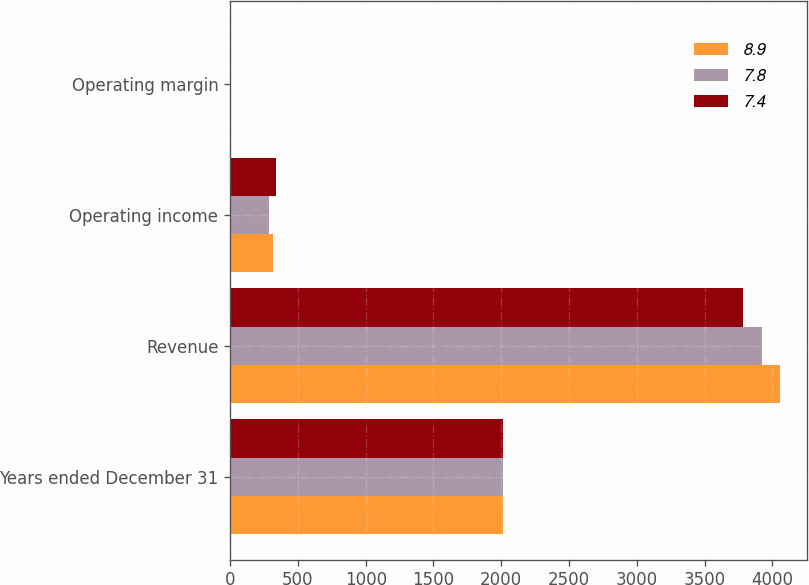<chart> <loc_0><loc_0><loc_500><loc_500><stacked_bar_chart><ecel><fcel>Years ended December 31<fcel>Revenue<fcel>Operating income<fcel>Operating margin<nl><fcel>8.9<fcel>2013<fcel>4057<fcel>318<fcel>7.8<nl><fcel>7.8<fcel>2012<fcel>3925<fcel>289<fcel>7.4<nl><fcel>7.4<fcel>2011<fcel>3781<fcel>336<fcel>8.9<nl></chart> 